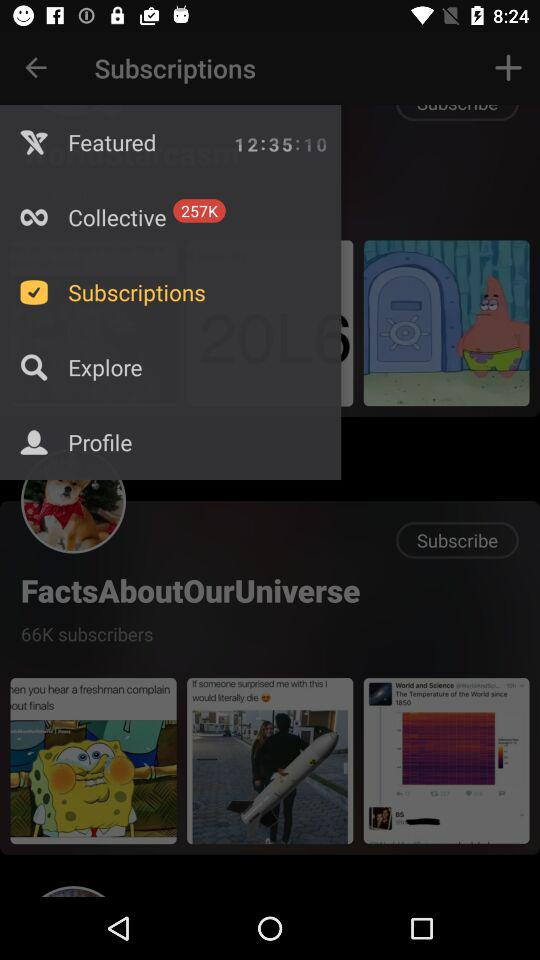What is the time shown on the screen? The time shown on the screen is 12:35:10. 